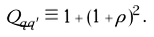Convert formula to latex. <formula><loc_0><loc_0><loc_500><loc_500>Q _ { q q ^ { \prime } } \equiv 1 + ( 1 + \rho ) ^ { 2 } \, .</formula> 